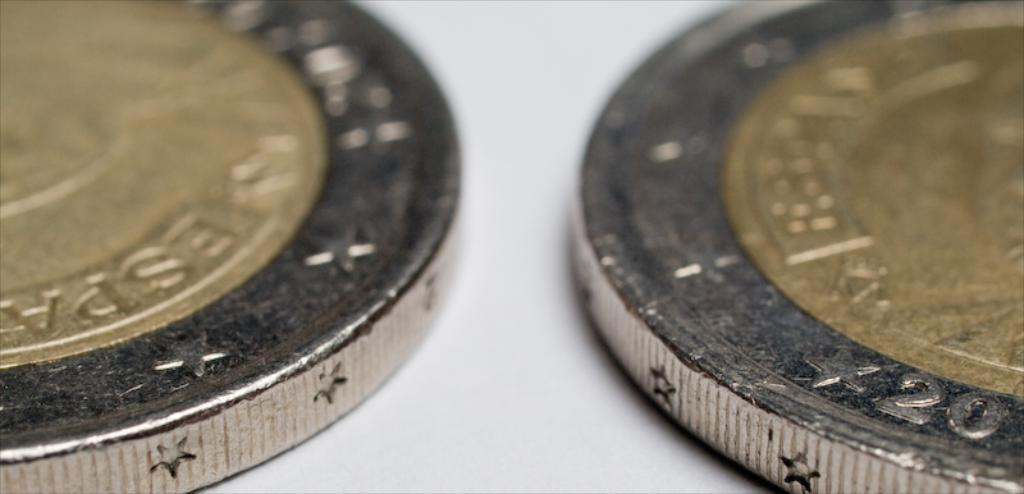<image>
Describe the image concisely. Twenty and several stars are etched into the edge of this coin. 